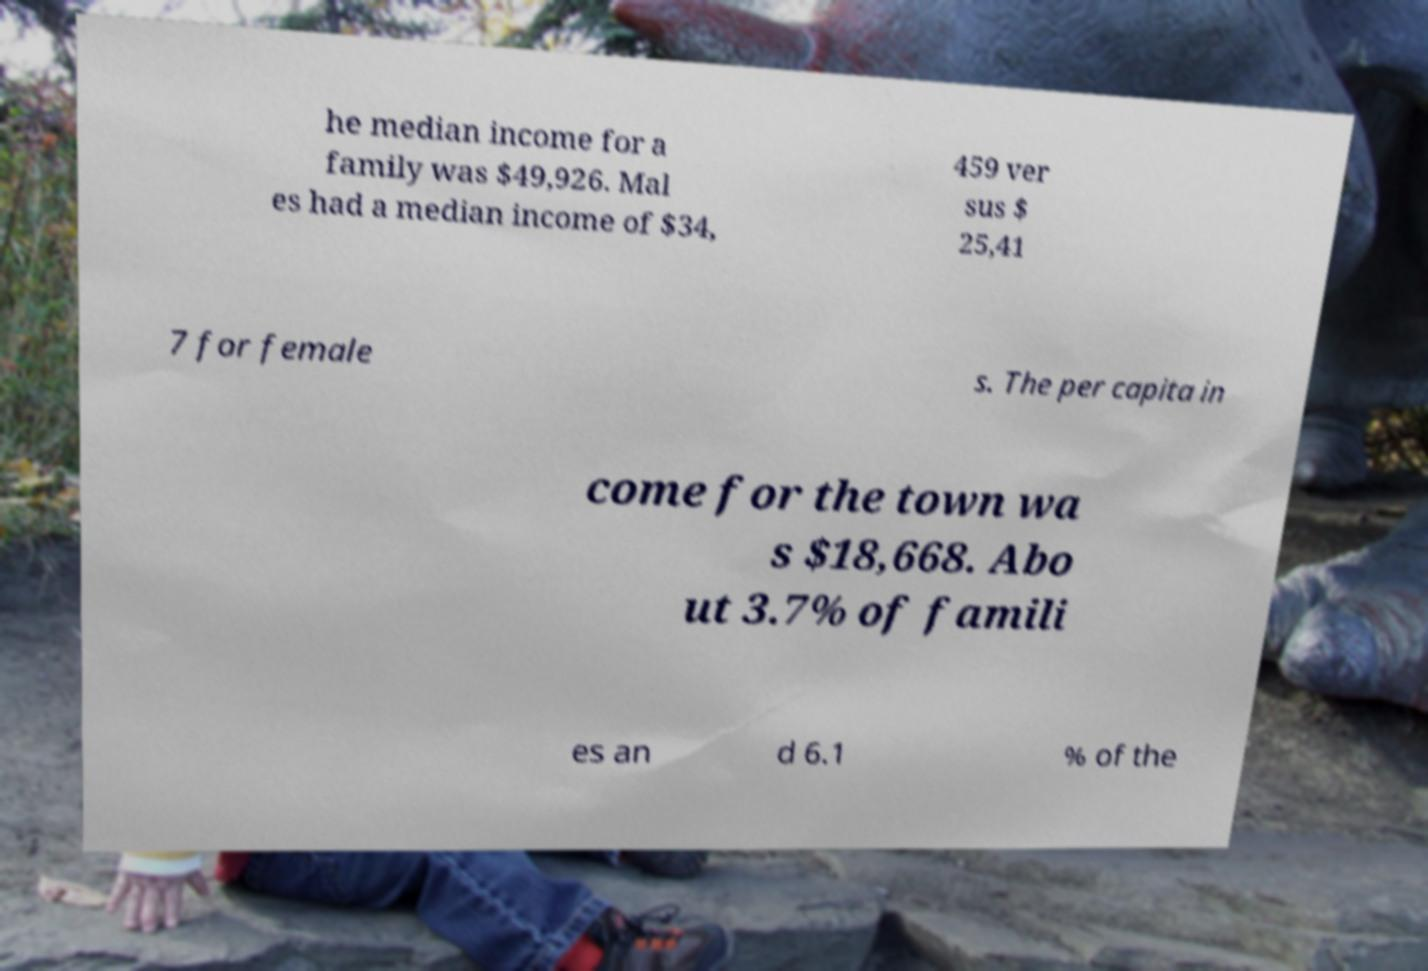There's text embedded in this image that I need extracted. Can you transcribe it verbatim? he median income for a family was $49,926. Mal es had a median income of $34, 459 ver sus $ 25,41 7 for female s. The per capita in come for the town wa s $18,668. Abo ut 3.7% of famili es an d 6.1 % of the 